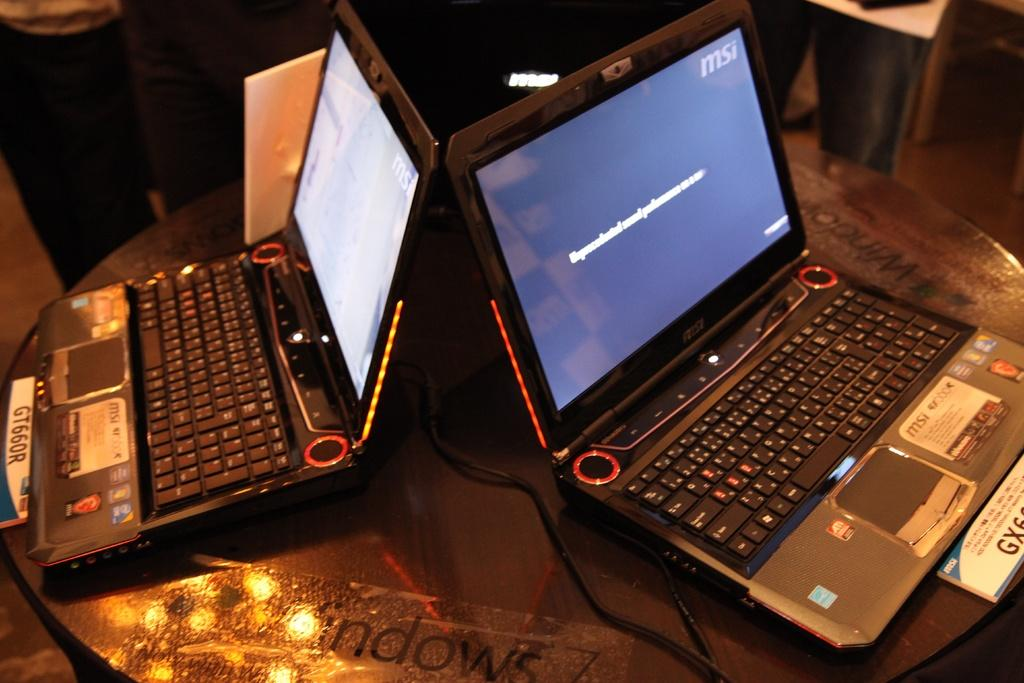<image>
Provide a brief description of the given image. A windows 7 sticker on a table between two laptops. 